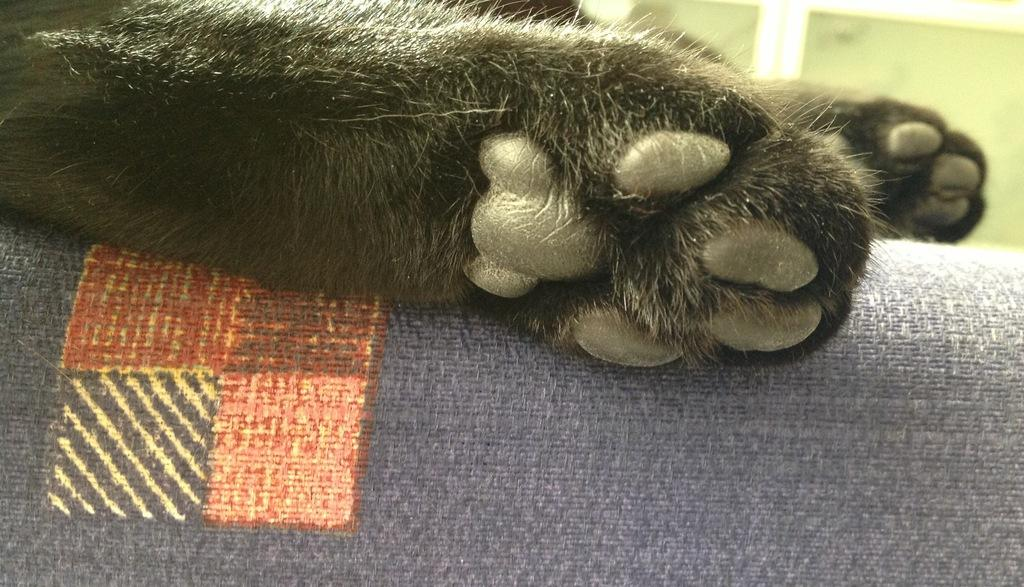What type of animal is in the image? The type of animal cannot be determined from the provided facts. Where are the animal's legs positioned in the image? The animal's legs are on a couch. What can be seen behind the couch in the image? There is a wall visible in the background of the image. What type of quartz is present on the couch in the image? There is no quartz present in the image; it features an animal with its legs on a couch and a wall visible in the background. 